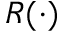Convert formula to latex. <formula><loc_0><loc_0><loc_500><loc_500>R ( \cdot )</formula> 